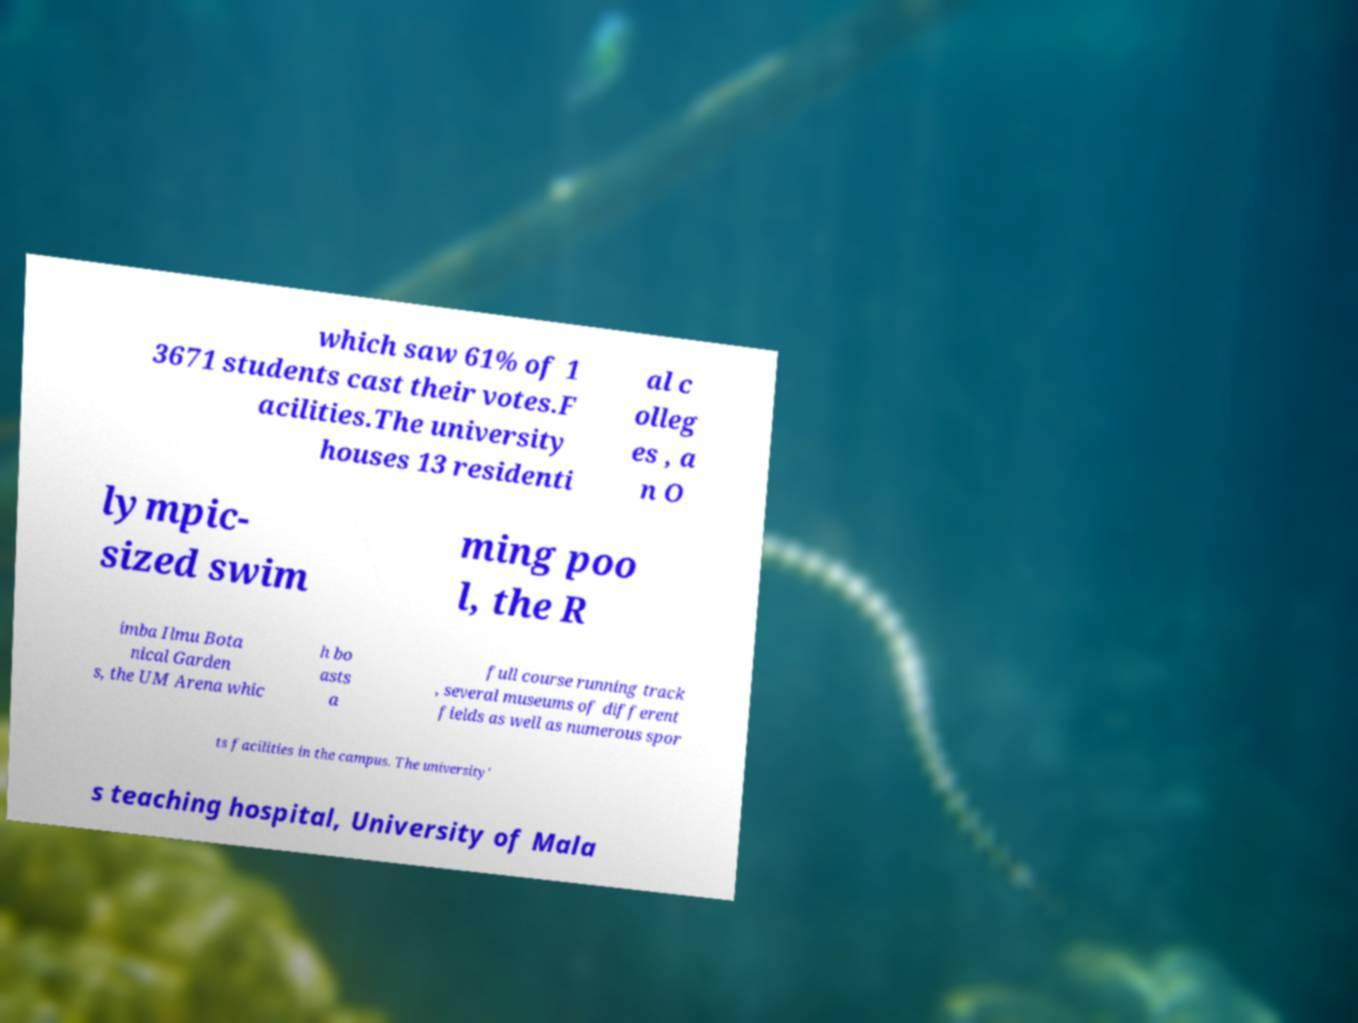I need the written content from this picture converted into text. Can you do that? which saw 61% of 1 3671 students cast their votes.F acilities.The university houses 13 residenti al c olleg es , a n O lympic- sized swim ming poo l, the R imba Ilmu Bota nical Garden s, the UM Arena whic h bo asts a full course running track , several museums of different fields as well as numerous spor ts facilities in the campus. The university' s teaching hospital, University of Mala 